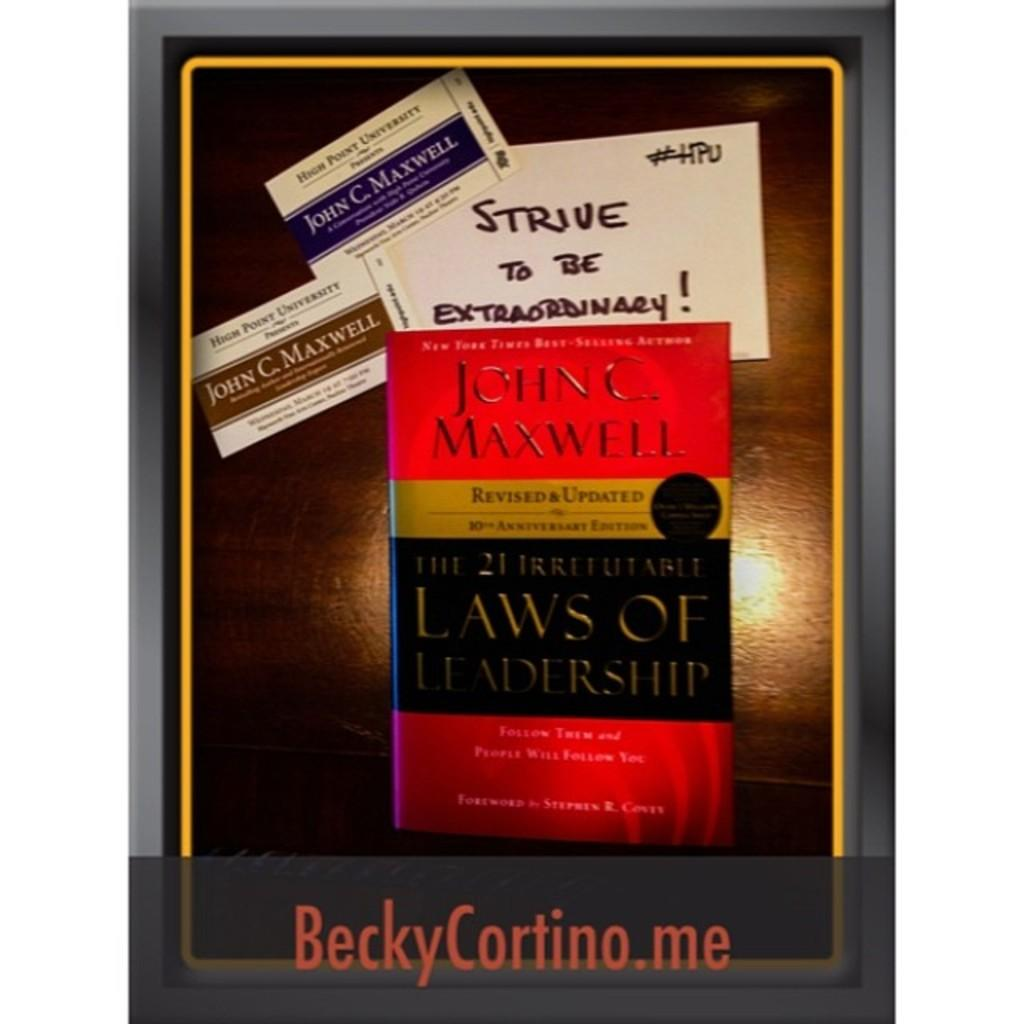<image>
Write a terse but informative summary of the picture. A book has several business cards next to it that say John C. Maxwell. 